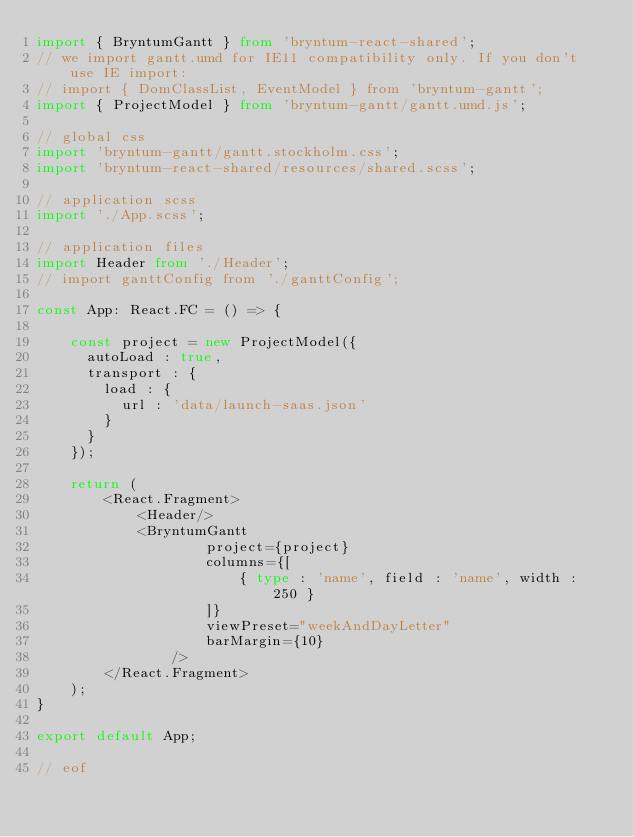Convert code to text. <code><loc_0><loc_0><loc_500><loc_500><_TypeScript_>import { BryntumGantt } from 'bryntum-react-shared';
// we import gantt.umd for IE11 compatibility only. If you don't use IE import:
// import { DomClassList, EventModel } from 'bryntum-gantt';
import { ProjectModel } from 'bryntum-gantt/gantt.umd.js';

// global css
import 'bryntum-gantt/gantt.stockholm.css';
import 'bryntum-react-shared/resources/shared.scss';

// application scss
import './App.scss';

// application files
import Header from './Header';
// import ganttConfig from './ganttConfig';

const App: React.FC = () => {

    const project = new ProjectModel({
      autoLoad : true,
      transport : {
        load : {
          url : 'data/launch-saas.json'
        }
      }
    });

    return (
        <React.Fragment>
            <Header/>
            <BryntumGantt
                    project={project}
                    columns={[
                        { type : 'name', field : 'name', width : 250 }
                    ]}
                    viewPreset="weekAndDayLetter"
                    barMargin={10}
                />
        </React.Fragment>
    );
}

export default App;

// eof</code> 